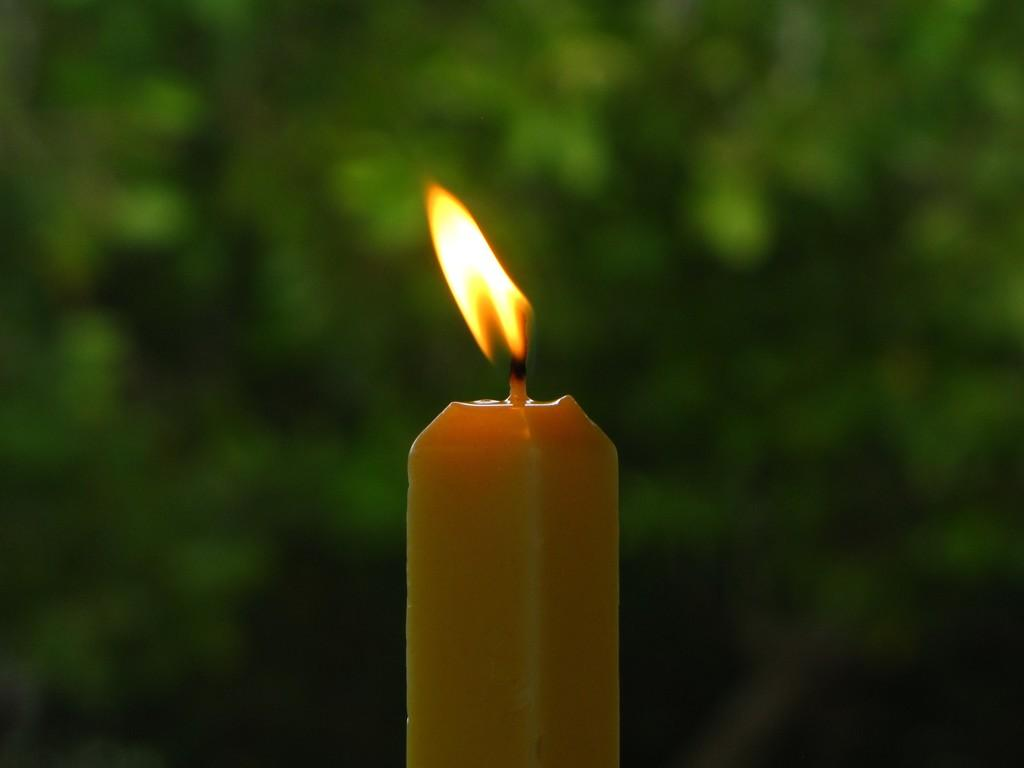What object can be seen in the image? There is a candle in the image. What type of animals can be seen at the zoo in the image? There is no zoo present in the image, and therefore no animals can be observed. Is there a swing visible in the image? No, there is no swing present in the image. 